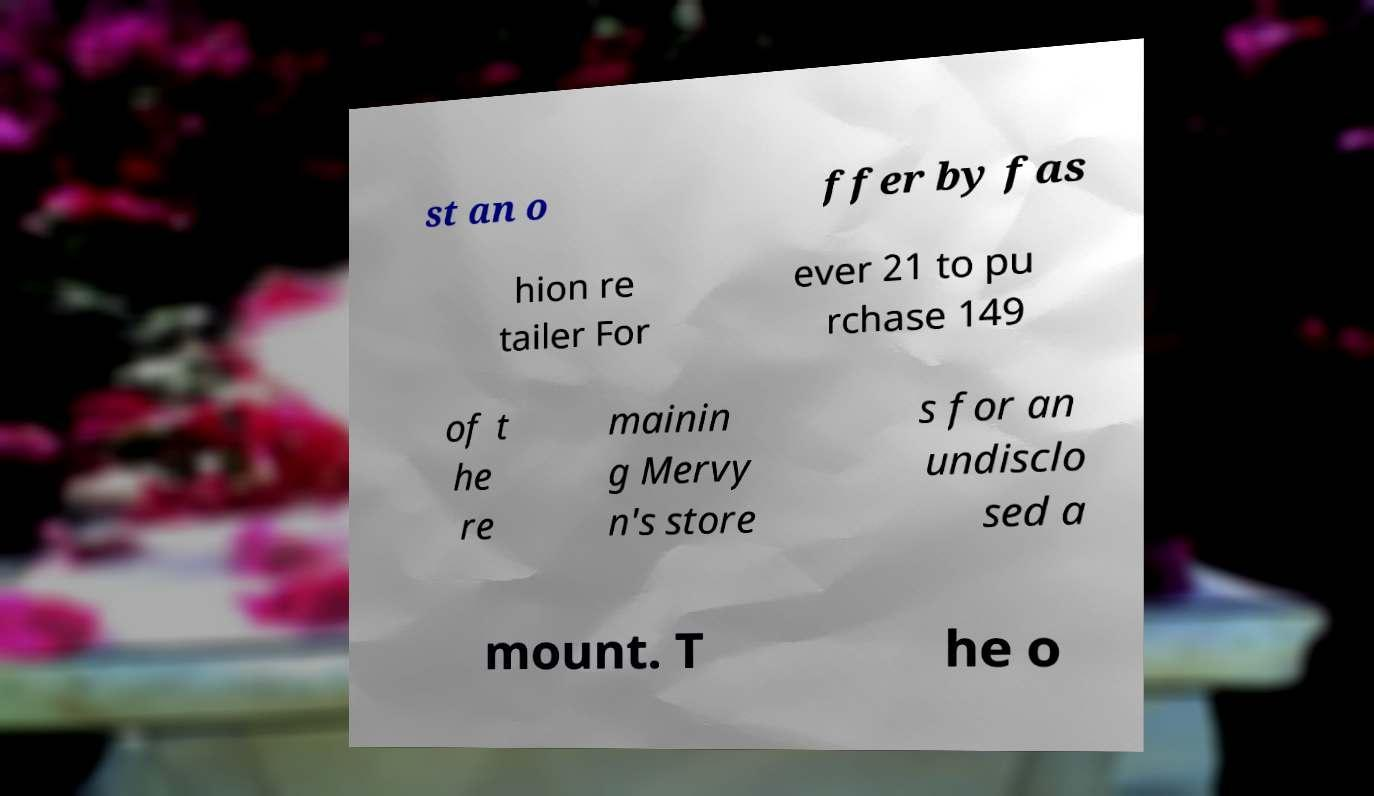I need the written content from this picture converted into text. Can you do that? st an o ffer by fas hion re tailer For ever 21 to pu rchase 149 of t he re mainin g Mervy n's store s for an undisclo sed a mount. T he o 